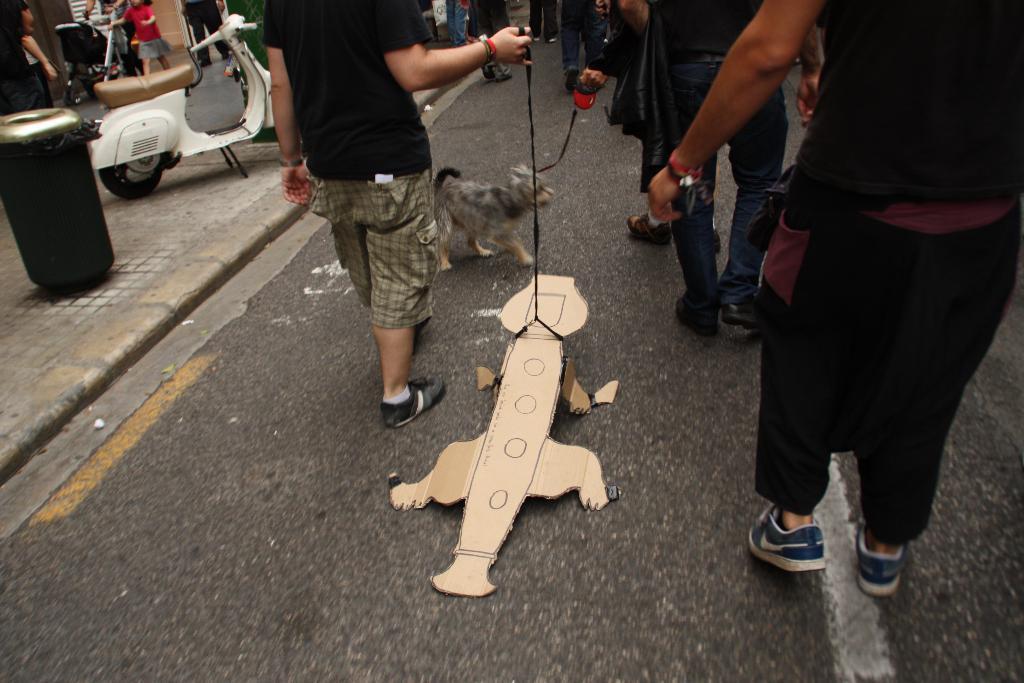Describe this image in one or two sentences. Here in this picture we can see number of people walking on the road over there and some people are carrying dogs with them, as we can see belts in their hands and in the front we can see an animal prepared with a cardboard present over there and on the left side we can see a scooter and a dustbin present over there. 